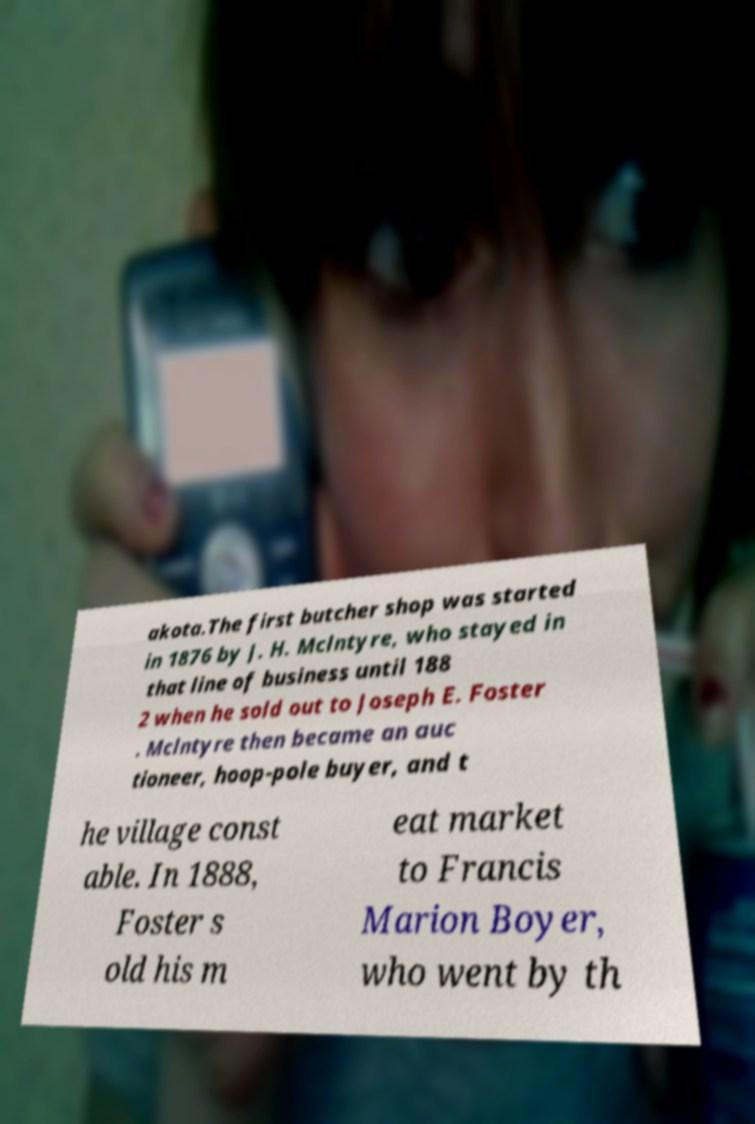Could you extract and type out the text from this image? akota.The first butcher shop was started in 1876 by J. H. Mclntyre, who stayed in that line of business until 188 2 when he sold out to Joseph E. Foster . Mclntyre then became an auc tioneer, hoop-pole buyer, and t he village const able. In 1888, Foster s old his m eat market to Francis Marion Boyer, who went by th 